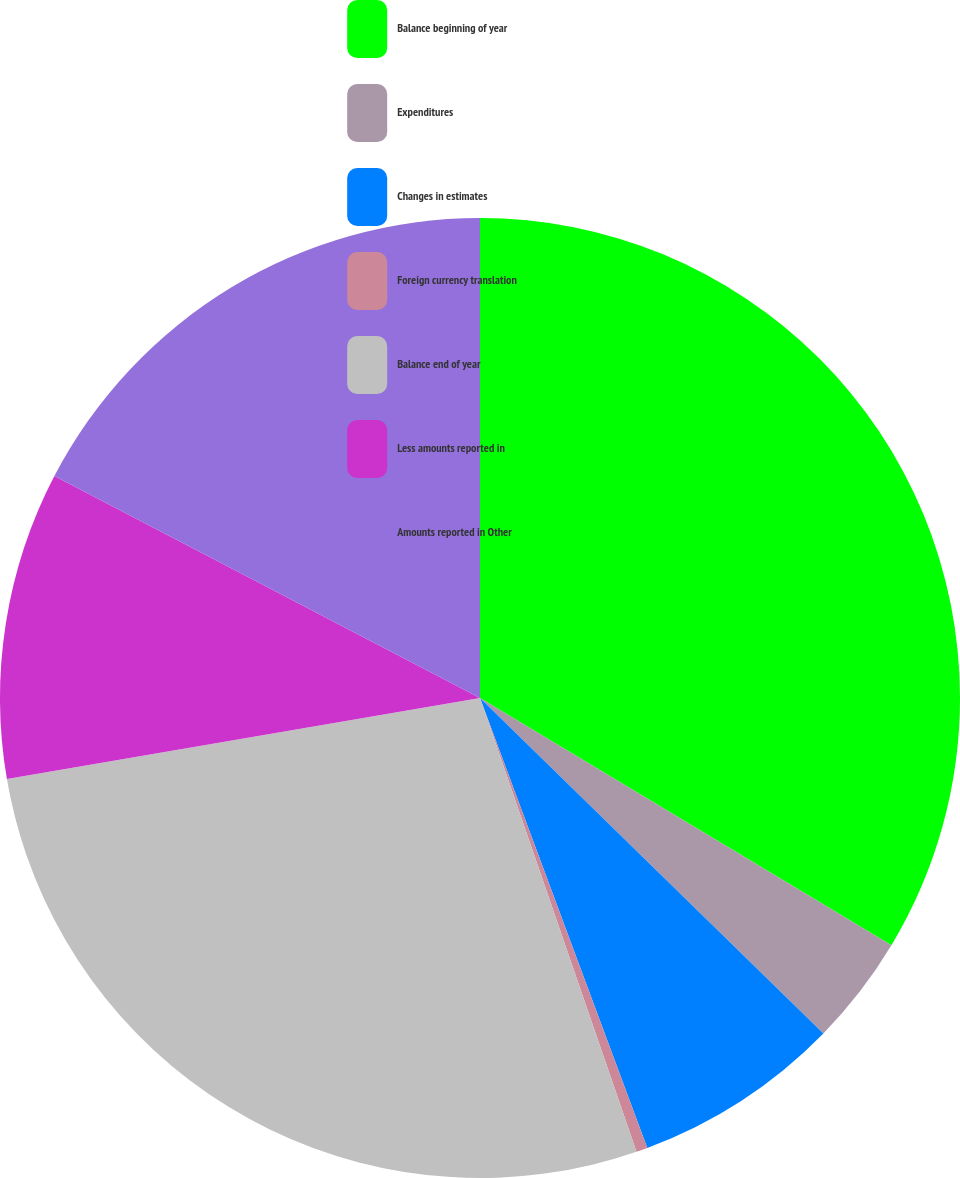Convert chart to OTSL. <chart><loc_0><loc_0><loc_500><loc_500><pie_chart><fcel>Balance beginning of year<fcel>Expenditures<fcel>Changes in estimates<fcel>Foreign currency translation<fcel>Balance end of year<fcel>Less amounts reported in<fcel>Amounts reported in Other<nl><fcel>33.61%<fcel>3.7%<fcel>7.02%<fcel>0.38%<fcel>27.58%<fcel>10.35%<fcel>17.35%<nl></chart> 